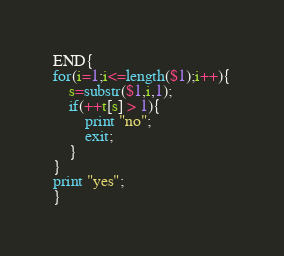<code> <loc_0><loc_0><loc_500><loc_500><_Awk_>END{
for(i=1;i<=length($1);i++){
	s=substr($1,i,1);
    if(++t[s] > 1){
    	print "no";
        exit;
    }
}
print "yes";
}</code> 